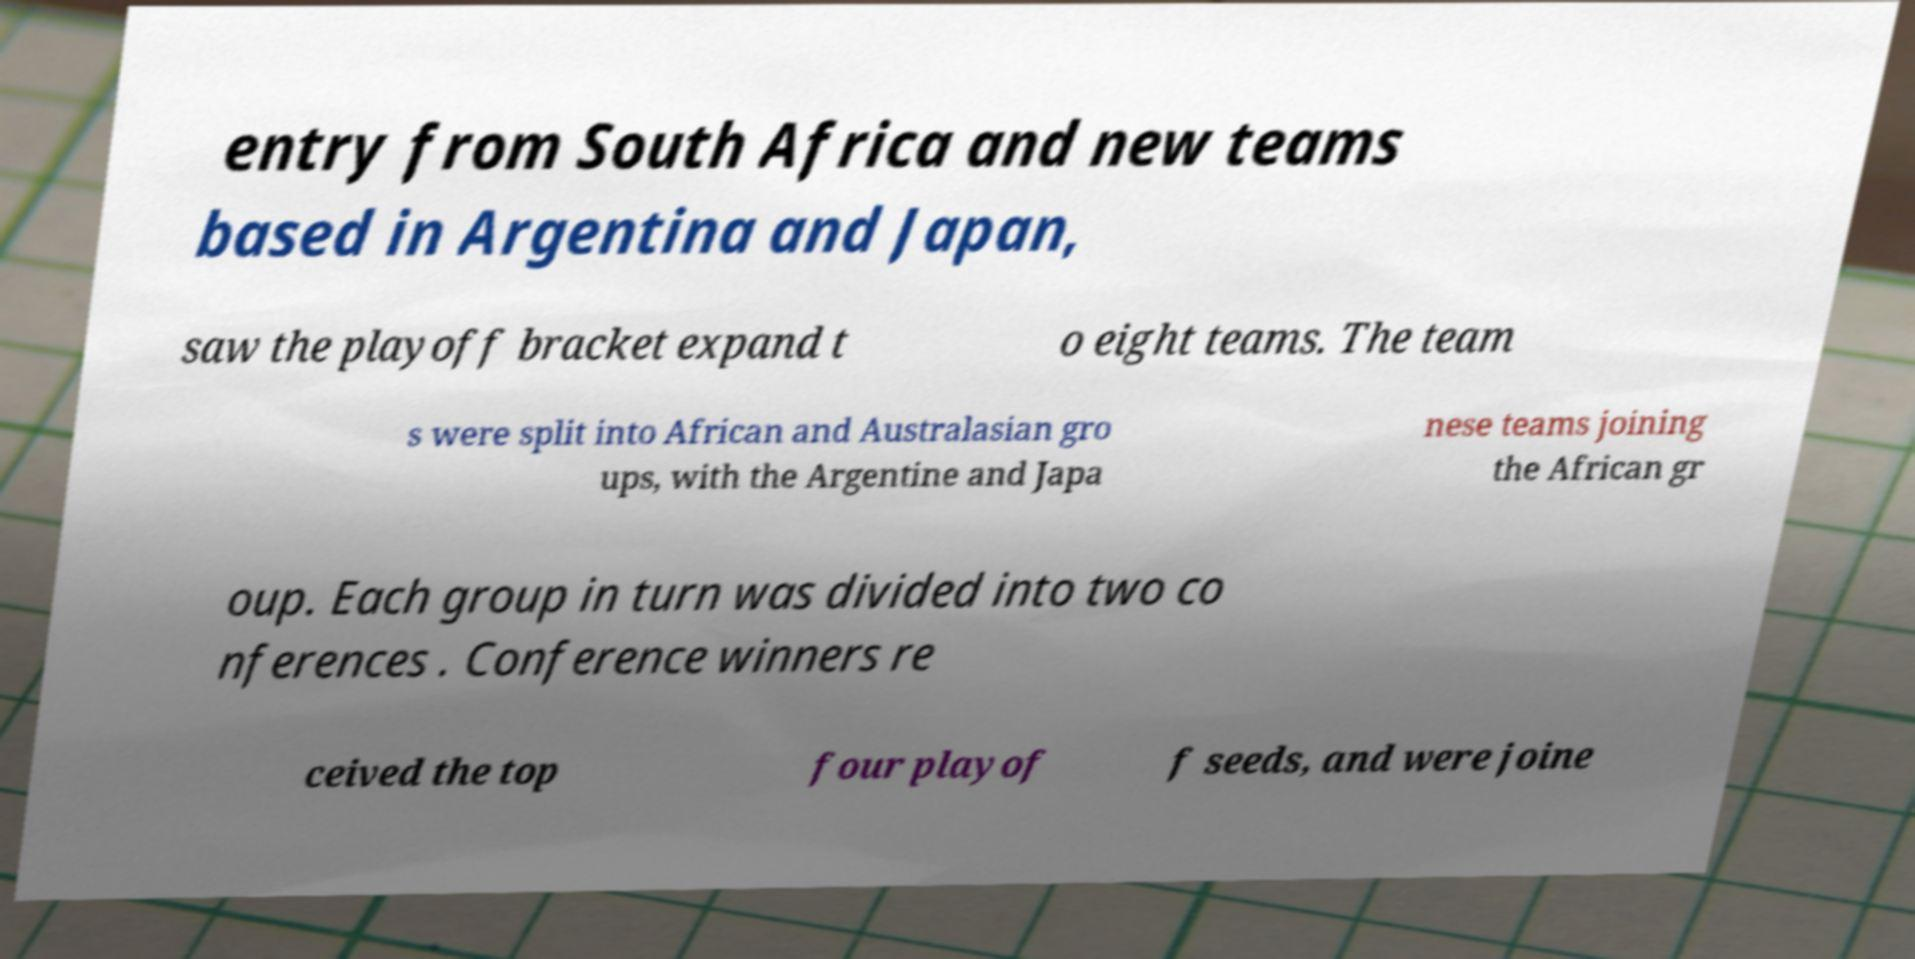Please read and relay the text visible in this image. What does it say? entry from South Africa and new teams based in Argentina and Japan, saw the playoff bracket expand t o eight teams. The team s were split into African and Australasian gro ups, with the Argentine and Japa nese teams joining the African gr oup. Each group in turn was divided into two co nferences . Conference winners re ceived the top four playof f seeds, and were joine 